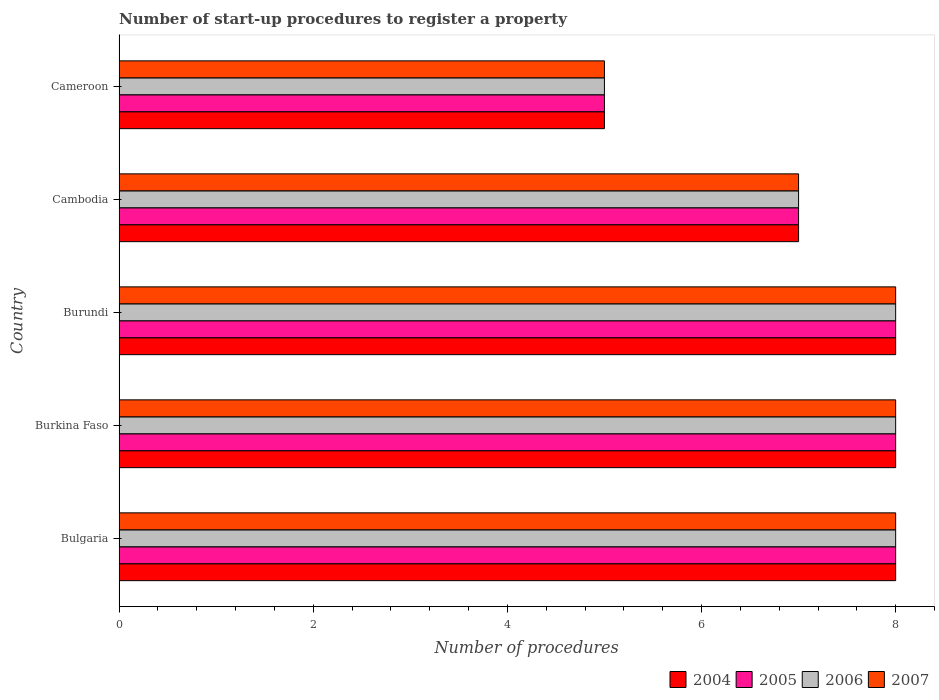How many groups of bars are there?
Offer a terse response. 5. Are the number of bars on each tick of the Y-axis equal?
Ensure brevity in your answer.  Yes. How many bars are there on the 1st tick from the top?
Make the answer very short. 4. How many bars are there on the 5th tick from the bottom?
Give a very brief answer. 4. What is the label of the 2nd group of bars from the top?
Ensure brevity in your answer.  Cambodia. In how many cases, is the number of bars for a given country not equal to the number of legend labels?
Offer a very short reply. 0. Across all countries, what is the maximum number of procedures required to register a property in 2006?
Provide a short and direct response. 8. Across all countries, what is the minimum number of procedures required to register a property in 2004?
Your answer should be compact. 5. In which country was the number of procedures required to register a property in 2007 maximum?
Give a very brief answer. Bulgaria. In which country was the number of procedures required to register a property in 2004 minimum?
Make the answer very short. Cameroon. What is the total number of procedures required to register a property in 2006 in the graph?
Your answer should be compact. 36. In how many countries, is the number of procedures required to register a property in 2007 greater than 4 ?
Provide a short and direct response. 5. What is the ratio of the number of procedures required to register a property in 2004 in Bulgaria to that in Cameroon?
Keep it short and to the point. 1.6. Is the difference between the number of procedures required to register a property in 2005 in Cambodia and Cameroon greater than the difference between the number of procedures required to register a property in 2007 in Cambodia and Cameroon?
Give a very brief answer. No. What is the difference between the highest and the second highest number of procedures required to register a property in 2005?
Offer a terse response. 0. What is the difference between the highest and the lowest number of procedures required to register a property in 2006?
Your response must be concise. 3. In how many countries, is the number of procedures required to register a property in 2005 greater than the average number of procedures required to register a property in 2005 taken over all countries?
Provide a succinct answer. 3. Is it the case that in every country, the sum of the number of procedures required to register a property in 2006 and number of procedures required to register a property in 2007 is greater than the sum of number of procedures required to register a property in 2004 and number of procedures required to register a property in 2005?
Keep it short and to the point. No. What does the 3rd bar from the top in Bulgaria represents?
Your response must be concise. 2005. What does the 3rd bar from the bottom in Burundi represents?
Offer a very short reply. 2006. Is it the case that in every country, the sum of the number of procedures required to register a property in 2006 and number of procedures required to register a property in 2004 is greater than the number of procedures required to register a property in 2007?
Your answer should be very brief. Yes. Are all the bars in the graph horizontal?
Your response must be concise. Yes. What is the difference between two consecutive major ticks on the X-axis?
Ensure brevity in your answer.  2. Does the graph contain any zero values?
Offer a very short reply. No. Does the graph contain grids?
Provide a short and direct response. No. Where does the legend appear in the graph?
Your answer should be very brief. Bottom right. How many legend labels are there?
Your response must be concise. 4. What is the title of the graph?
Provide a short and direct response. Number of start-up procedures to register a property. Does "1984" appear as one of the legend labels in the graph?
Provide a succinct answer. No. What is the label or title of the X-axis?
Ensure brevity in your answer.  Number of procedures. What is the Number of procedures of 2004 in Bulgaria?
Your answer should be very brief. 8. What is the Number of procedures of 2005 in Bulgaria?
Your answer should be compact. 8. What is the Number of procedures in 2007 in Bulgaria?
Give a very brief answer. 8. What is the Number of procedures of 2005 in Burkina Faso?
Give a very brief answer. 8. What is the Number of procedures in 2006 in Burkina Faso?
Make the answer very short. 8. What is the Number of procedures of 2004 in Burundi?
Provide a succinct answer. 8. What is the Number of procedures in 2004 in Cambodia?
Offer a very short reply. 7. What is the Number of procedures of 2006 in Cambodia?
Offer a terse response. 7. What is the Number of procedures in 2007 in Cambodia?
Make the answer very short. 7. What is the Number of procedures of 2004 in Cameroon?
Give a very brief answer. 5. What is the Number of procedures of 2005 in Cameroon?
Ensure brevity in your answer.  5. Across all countries, what is the maximum Number of procedures of 2005?
Offer a terse response. 8. Across all countries, what is the minimum Number of procedures in 2004?
Your response must be concise. 5. Across all countries, what is the minimum Number of procedures in 2006?
Offer a very short reply. 5. What is the total Number of procedures of 2006 in the graph?
Your answer should be compact. 36. What is the difference between the Number of procedures in 2004 in Bulgaria and that in Burkina Faso?
Ensure brevity in your answer.  0. What is the difference between the Number of procedures of 2005 in Bulgaria and that in Burkina Faso?
Your response must be concise. 0. What is the difference between the Number of procedures in 2004 in Bulgaria and that in Burundi?
Provide a succinct answer. 0. What is the difference between the Number of procedures of 2005 in Bulgaria and that in Burundi?
Your response must be concise. 0. What is the difference between the Number of procedures in 2006 in Bulgaria and that in Burundi?
Give a very brief answer. 0. What is the difference between the Number of procedures of 2006 in Bulgaria and that in Cambodia?
Keep it short and to the point. 1. What is the difference between the Number of procedures in 2007 in Bulgaria and that in Cambodia?
Provide a short and direct response. 1. What is the difference between the Number of procedures in 2004 in Bulgaria and that in Cameroon?
Your answer should be compact. 3. What is the difference between the Number of procedures of 2006 in Bulgaria and that in Cameroon?
Offer a very short reply. 3. What is the difference between the Number of procedures in 2007 in Bulgaria and that in Cameroon?
Offer a very short reply. 3. What is the difference between the Number of procedures in 2007 in Burkina Faso and that in Burundi?
Your response must be concise. 0. What is the difference between the Number of procedures of 2004 in Burkina Faso and that in Cambodia?
Give a very brief answer. 1. What is the difference between the Number of procedures of 2006 in Burkina Faso and that in Cambodia?
Provide a short and direct response. 1. What is the difference between the Number of procedures of 2004 in Burkina Faso and that in Cameroon?
Make the answer very short. 3. What is the difference between the Number of procedures in 2005 in Burkina Faso and that in Cameroon?
Your response must be concise. 3. What is the difference between the Number of procedures in 2007 in Burkina Faso and that in Cameroon?
Provide a succinct answer. 3. What is the difference between the Number of procedures of 2006 in Burundi and that in Cambodia?
Your answer should be very brief. 1. What is the difference between the Number of procedures of 2004 in Burundi and that in Cameroon?
Give a very brief answer. 3. What is the difference between the Number of procedures in 2006 in Burundi and that in Cameroon?
Your response must be concise. 3. What is the difference between the Number of procedures of 2004 in Cambodia and that in Cameroon?
Ensure brevity in your answer.  2. What is the difference between the Number of procedures of 2005 in Cambodia and that in Cameroon?
Make the answer very short. 2. What is the difference between the Number of procedures of 2004 in Bulgaria and the Number of procedures of 2005 in Burkina Faso?
Your answer should be very brief. 0. What is the difference between the Number of procedures in 2004 in Bulgaria and the Number of procedures in 2007 in Burkina Faso?
Make the answer very short. 0. What is the difference between the Number of procedures of 2005 in Bulgaria and the Number of procedures of 2006 in Burkina Faso?
Ensure brevity in your answer.  0. What is the difference between the Number of procedures in 2005 in Bulgaria and the Number of procedures in 2007 in Burkina Faso?
Offer a very short reply. 0. What is the difference between the Number of procedures of 2004 in Bulgaria and the Number of procedures of 2005 in Burundi?
Provide a short and direct response. 0. What is the difference between the Number of procedures in 2004 in Bulgaria and the Number of procedures in 2007 in Burundi?
Give a very brief answer. 0. What is the difference between the Number of procedures in 2005 in Bulgaria and the Number of procedures in 2006 in Burundi?
Offer a terse response. 0. What is the difference between the Number of procedures in 2005 in Bulgaria and the Number of procedures in 2007 in Burundi?
Offer a terse response. 0. What is the difference between the Number of procedures of 2006 in Bulgaria and the Number of procedures of 2007 in Burundi?
Provide a short and direct response. 0. What is the difference between the Number of procedures in 2004 in Bulgaria and the Number of procedures in 2005 in Cambodia?
Your answer should be very brief. 1. What is the difference between the Number of procedures of 2004 in Bulgaria and the Number of procedures of 2006 in Cambodia?
Offer a very short reply. 1. What is the difference between the Number of procedures of 2005 in Bulgaria and the Number of procedures of 2007 in Cambodia?
Your answer should be compact. 1. What is the difference between the Number of procedures of 2006 in Bulgaria and the Number of procedures of 2007 in Cambodia?
Provide a short and direct response. 1. What is the difference between the Number of procedures of 2004 in Bulgaria and the Number of procedures of 2005 in Cameroon?
Ensure brevity in your answer.  3. What is the difference between the Number of procedures of 2004 in Bulgaria and the Number of procedures of 2006 in Cameroon?
Make the answer very short. 3. What is the difference between the Number of procedures in 2005 in Bulgaria and the Number of procedures in 2007 in Cameroon?
Provide a succinct answer. 3. What is the difference between the Number of procedures in 2004 in Burkina Faso and the Number of procedures in 2005 in Burundi?
Keep it short and to the point. 0. What is the difference between the Number of procedures of 2004 in Burkina Faso and the Number of procedures of 2007 in Burundi?
Give a very brief answer. 0. What is the difference between the Number of procedures in 2005 in Burkina Faso and the Number of procedures in 2006 in Burundi?
Make the answer very short. 0. What is the difference between the Number of procedures of 2006 in Burkina Faso and the Number of procedures of 2007 in Burundi?
Offer a terse response. 0. What is the difference between the Number of procedures of 2004 in Burkina Faso and the Number of procedures of 2006 in Cambodia?
Make the answer very short. 1. What is the difference between the Number of procedures of 2005 in Burkina Faso and the Number of procedures of 2007 in Cambodia?
Give a very brief answer. 1. What is the difference between the Number of procedures in 2006 in Burkina Faso and the Number of procedures in 2007 in Cambodia?
Offer a very short reply. 1. What is the difference between the Number of procedures in 2004 in Burkina Faso and the Number of procedures in 2006 in Cameroon?
Your answer should be very brief. 3. What is the difference between the Number of procedures of 2004 in Burundi and the Number of procedures of 2005 in Cambodia?
Your answer should be very brief. 1. What is the difference between the Number of procedures of 2004 in Burundi and the Number of procedures of 2006 in Cambodia?
Offer a terse response. 1. What is the difference between the Number of procedures of 2005 in Burundi and the Number of procedures of 2006 in Cambodia?
Offer a very short reply. 1. What is the difference between the Number of procedures in 2005 in Burundi and the Number of procedures in 2007 in Cambodia?
Offer a terse response. 1. What is the difference between the Number of procedures in 2006 in Burundi and the Number of procedures in 2007 in Cambodia?
Provide a succinct answer. 1. What is the difference between the Number of procedures in 2004 in Burundi and the Number of procedures in 2006 in Cameroon?
Ensure brevity in your answer.  3. What is the difference between the Number of procedures in 2004 in Burundi and the Number of procedures in 2007 in Cameroon?
Ensure brevity in your answer.  3. What is the difference between the Number of procedures in 2005 in Burundi and the Number of procedures in 2006 in Cameroon?
Give a very brief answer. 3. What is the difference between the Number of procedures of 2005 in Burundi and the Number of procedures of 2007 in Cameroon?
Provide a short and direct response. 3. What is the difference between the Number of procedures of 2006 in Burundi and the Number of procedures of 2007 in Cameroon?
Your answer should be very brief. 3. What is the difference between the Number of procedures in 2004 in Cambodia and the Number of procedures in 2005 in Cameroon?
Your answer should be very brief. 2. What is the difference between the Number of procedures of 2004 in Cambodia and the Number of procedures of 2006 in Cameroon?
Provide a short and direct response. 2. What is the difference between the Number of procedures in 2004 in Cambodia and the Number of procedures in 2007 in Cameroon?
Your answer should be very brief. 2. What is the average Number of procedures of 2004 per country?
Offer a very short reply. 7.2. What is the average Number of procedures of 2005 per country?
Your answer should be compact. 7.2. What is the difference between the Number of procedures in 2004 and Number of procedures in 2005 in Bulgaria?
Provide a short and direct response. 0. What is the difference between the Number of procedures of 2004 and Number of procedures of 2006 in Bulgaria?
Provide a short and direct response. 0. What is the difference between the Number of procedures in 2005 and Number of procedures in 2007 in Bulgaria?
Give a very brief answer. 0. What is the difference between the Number of procedures in 2004 and Number of procedures in 2007 in Burkina Faso?
Ensure brevity in your answer.  0. What is the difference between the Number of procedures of 2005 and Number of procedures of 2006 in Burkina Faso?
Give a very brief answer. 0. What is the difference between the Number of procedures of 2006 and Number of procedures of 2007 in Burkina Faso?
Keep it short and to the point. 0. What is the difference between the Number of procedures of 2004 and Number of procedures of 2006 in Burundi?
Give a very brief answer. 0. What is the difference between the Number of procedures of 2005 and Number of procedures of 2007 in Burundi?
Keep it short and to the point. 0. What is the difference between the Number of procedures in 2004 and Number of procedures in 2005 in Cambodia?
Give a very brief answer. 0. What is the difference between the Number of procedures in 2005 and Number of procedures in 2006 in Cambodia?
Offer a very short reply. 0. What is the difference between the Number of procedures of 2005 and Number of procedures of 2007 in Cambodia?
Provide a succinct answer. 0. What is the difference between the Number of procedures in 2004 and Number of procedures in 2005 in Cameroon?
Offer a very short reply. 0. What is the difference between the Number of procedures of 2005 and Number of procedures of 2006 in Cameroon?
Provide a short and direct response. 0. What is the ratio of the Number of procedures of 2004 in Bulgaria to that in Burkina Faso?
Your answer should be compact. 1. What is the ratio of the Number of procedures in 2007 in Bulgaria to that in Burkina Faso?
Provide a short and direct response. 1. What is the ratio of the Number of procedures of 2006 in Bulgaria to that in Burundi?
Keep it short and to the point. 1. What is the ratio of the Number of procedures of 2007 in Bulgaria to that in Burundi?
Provide a short and direct response. 1. What is the ratio of the Number of procedures in 2004 in Bulgaria to that in Cambodia?
Ensure brevity in your answer.  1.14. What is the ratio of the Number of procedures of 2004 in Bulgaria to that in Cameroon?
Make the answer very short. 1.6. What is the ratio of the Number of procedures in 2005 in Burkina Faso to that in Burundi?
Offer a terse response. 1. What is the ratio of the Number of procedures of 2006 in Burkina Faso to that in Burundi?
Ensure brevity in your answer.  1. What is the ratio of the Number of procedures of 2004 in Burkina Faso to that in Cambodia?
Provide a short and direct response. 1.14. What is the ratio of the Number of procedures of 2005 in Burkina Faso to that in Cambodia?
Provide a succinct answer. 1.14. What is the ratio of the Number of procedures of 2006 in Burkina Faso to that in Cambodia?
Make the answer very short. 1.14. What is the ratio of the Number of procedures in 2007 in Burkina Faso to that in Cambodia?
Give a very brief answer. 1.14. What is the ratio of the Number of procedures in 2005 in Burkina Faso to that in Cameroon?
Your answer should be very brief. 1.6. What is the ratio of the Number of procedures in 2007 in Burkina Faso to that in Cameroon?
Keep it short and to the point. 1.6. What is the ratio of the Number of procedures of 2005 in Burundi to that in Cambodia?
Provide a short and direct response. 1.14. What is the ratio of the Number of procedures in 2007 in Burundi to that in Cambodia?
Ensure brevity in your answer.  1.14. What is the ratio of the Number of procedures in 2005 in Burundi to that in Cameroon?
Ensure brevity in your answer.  1.6. What is the ratio of the Number of procedures of 2006 in Burundi to that in Cameroon?
Provide a succinct answer. 1.6. What is the ratio of the Number of procedures in 2004 in Cambodia to that in Cameroon?
Keep it short and to the point. 1.4. What is the ratio of the Number of procedures of 2005 in Cambodia to that in Cameroon?
Make the answer very short. 1.4. What is the ratio of the Number of procedures in 2007 in Cambodia to that in Cameroon?
Offer a very short reply. 1.4. What is the difference between the highest and the second highest Number of procedures of 2004?
Give a very brief answer. 0. What is the difference between the highest and the second highest Number of procedures in 2005?
Give a very brief answer. 0. What is the difference between the highest and the second highest Number of procedures of 2006?
Your answer should be compact. 0. What is the difference between the highest and the second highest Number of procedures in 2007?
Give a very brief answer. 0. What is the difference between the highest and the lowest Number of procedures of 2004?
Offer a very short reply. 3. What is the difference between the highest and the lowest Number of procedures in 2005?
Your response must be concise. 3. 